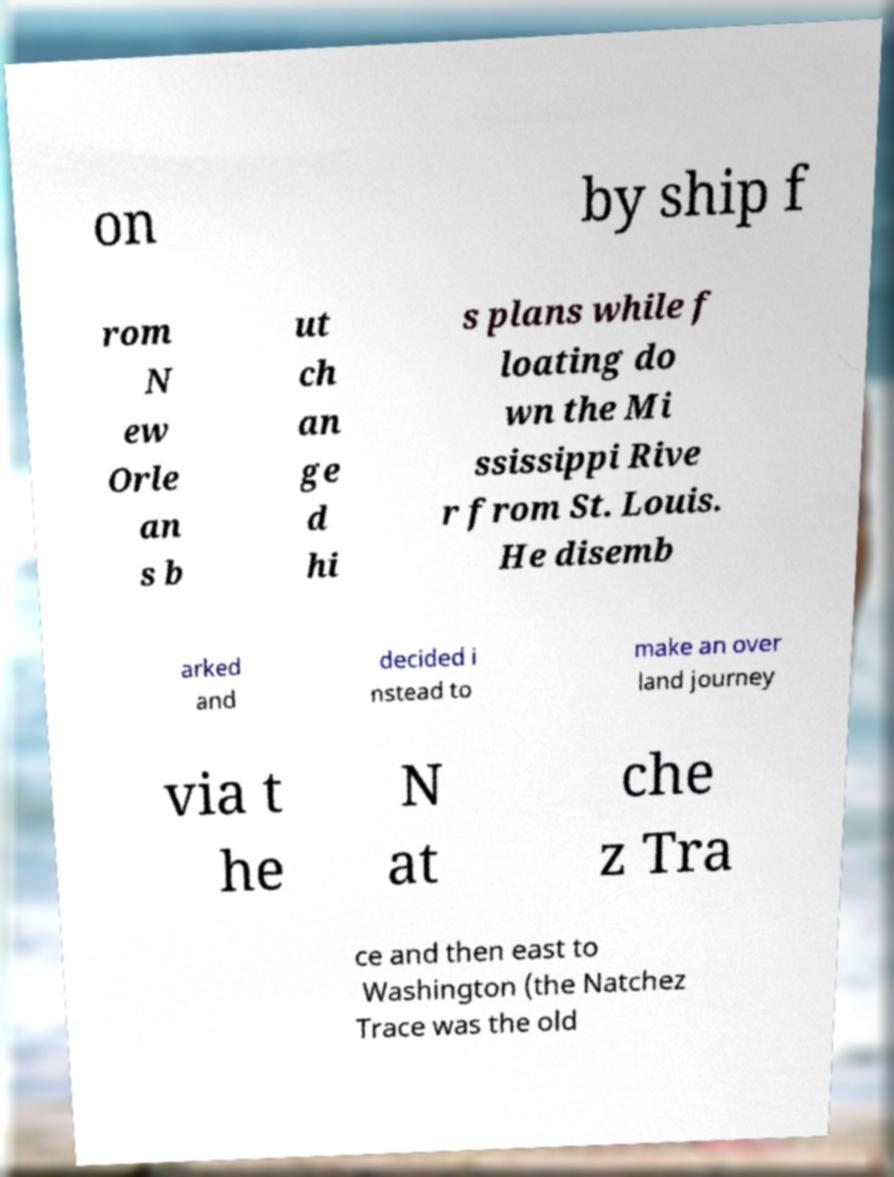There's text embedded in this image that I need extracted. Can you transcribe it verbatim? on by ship f rom N ew Orle an s b ut ch an ge d hi s plans while f loating do wn the Mi ssissippi Rive r from St. Louis. He disemb arked and decided i nstead to make an over land journey via t he N at che z Tra ce and then east to Washington (the Natchez Trace was the old 